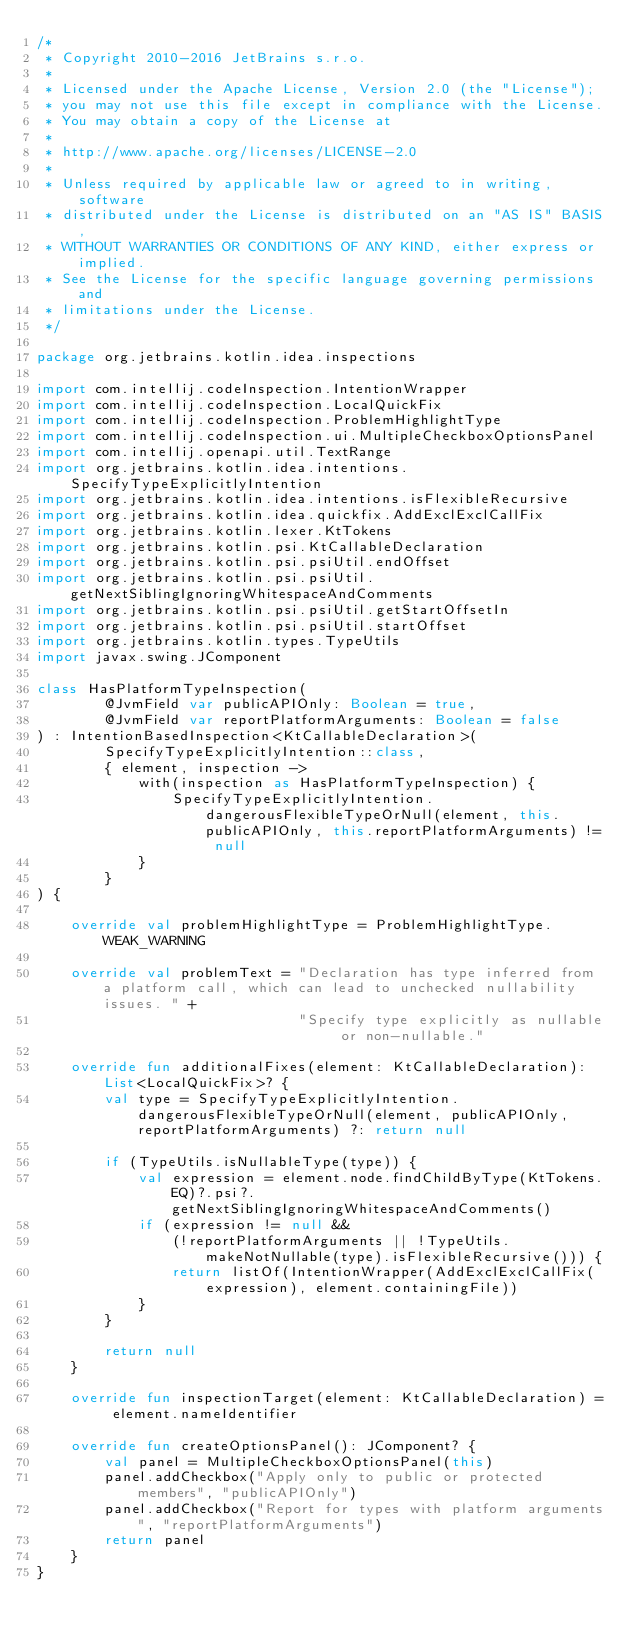Convert code to text. <code><loc_0><loc_0><loc_500><loc_500><_Kotlin_>/*
 * Copyright 2010-2016 JetBrains s.r.o.
 *
 * Licensed under the Apache License, Version 2.0 (the "License");
 * you may not use this file except in compliance with the License.
 * You may obtain a copy of the License at
 *
 * http://www.apache.org/licenses/LICENSE-2.0
 *
 * Unless required by applicable law or agreed to in writing, software
 * distributed under the License is distributed on an "AS IS" BASIS,
 * WITHOUT WARRANTIES OR CONDITIONS OF ANY KIND, either express or implied.
 * See the License for the specific language governing permissions and
 * limitations under the License.
 */

package org.jetbrains.kotlin.idea.inspections

import com.intellij.codeInspection.IntentionWrapper
import com.intellij.codeInspection.LocalQuickFix
import com.intellij.codeInspection.ProblemHighlightType
import com.intellij.codeInspection.ui.MultipleCheckboxOptionsPanel
import com.intellij.openapi.util.TextRange
import org.jetbrains.kotlin.idea.intentions.SpecifyTypeExplicitlyIntention
import org.jetbrains.kotlin.idea.intentions.isFlexibleRecursive
import org.jetbrains.kotlin.idea.quickfix.AddExclExclCallFix
import org.jetbrains.kotlin.lexer.KtTokens
import org.jetbrains.kotlin.psi.KtCallableDeclaration
import org.jetbrains.kotlin.psi.psiUtil.endOffset
import org.jetbrains.kotlin.psi.psiUtil.getNextSiblingIgnoringWhitespaceAndComments
import org.jetbrains.kotlin.psi.psiUtil.getStartOffsetIn
import org.jetbrains.kotlin.psi.psiUtil.startOffset
import org.jetbrains.kotlin.types.TypeUtils
import javax.swing.JComponent

class HasPlatformTypeInspection(
        @JvmField var publicAPIOnly: Boolean = true,
        @JvmField var reportPlatformArguments: Boolean = false
) : IntentionBasedInspection<KtCallableDeclaration>(
        SpecifyTypeExplicitlyIntention::class,
        { element, inspection ->
            with(inspection as HasPlatformTypeInspection) {
                SpecifyTypeExplicitlyIntention.dangerousFlexibleTypeOrNull(element, this.publicAPIOnly, this.reportPlatformArguments) != null
            }
        }
) {

    override val problemHighlightType = ProblemHighlightType.WEAK_WARNING

    override val problemText = "Declaration has type inferred from a platform call, which can lead to unchecked nullability issues. " +
                               "Specify type explicitly as nullable or non-nullable."

    override fun additionalFixes(element: KtCallableDeclaration): List<LocalQuickFix>? {
        val type = SpecifyTypeExplicitlyIntention.dangerousFlexibleTypeOrNull(element, publicAPIOnly, reportPlatformArguments) ?: return null

        if (TypeUtils.isNullableType(type)) {
            val expression = element.node.findChildByType(KtTokens.EQ)?.psi?.getNextSiblingIgnoringWhitespaceAndComments()
            if (expression != null &&
                (!reportPlatformArguments || !TypeUtils.makeNotNullable(type).isFlexibleRecursive())) {
                return listOf(IntentionWrapper(AddExclExclCallFix(expression), element.containingFile))
            }
        }

        return null
    }

    override fun inspectionTarget(element: KtCallableDeclaration) = element.nameIdentifier

    override fun createOptionsPanel(): JComponent? {
        val panel = MultipleCheckboxOptionsPanel(this)
        panel.addCheckbox("Apply only to public or protected members", "publicAPIOnly")
        panel.addCheckbox("Report for types with platform arguments", "reportPlatformArguments")
        return panel
    }
}</code> 